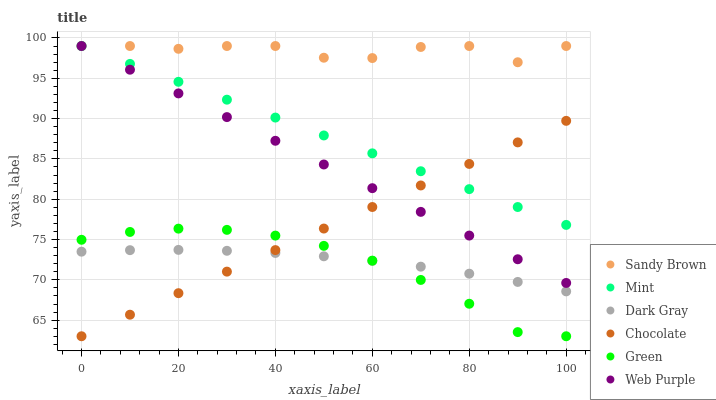Does Green have the minimum area under the curve?
Answer yes or no. Yes. Does Sandy Brown have the maximum area under the curve?
Answer yes or no. Yes. Does Chocolate have the minimum area under the curve?
Answer yes or no. No. Does Chocolate have the maximum area under the curve?
Answer yes or no. No. Is Web Purple the smoothest?
Answer yes or no. Yes. Is Sandy Brown the roughest?
Answer yes or no. Yes. Is Chocolate the smoothest?
Answer yes or no. No. Is Chocolate the roughest?
Answer yes or no. No. Does Chocolate have the lowest value?
Answer yes or no. Yes. Does Dark Gray have the lowest value?
Answer yes or no. No. Does Mint have the highest value?
Answer yes or no. Yes. Does Chocolate have the highest value?
Answer yes or no. No. Is Dark Gray less than Sandy Brown?
Answer yes or no. Yes. Is Web Purple greater than Green?
Answer yes or no. Yes. Does Mint intersect Web Purple?
Answer yes or no. Yes. Is Mint less than Web Purple?
Answer yes or no. No. Is Mint greater than Web Purple?
Answer yes or no. No. Does Dark Gray intersect Sandy Brown?
Answer yes or no. No. 